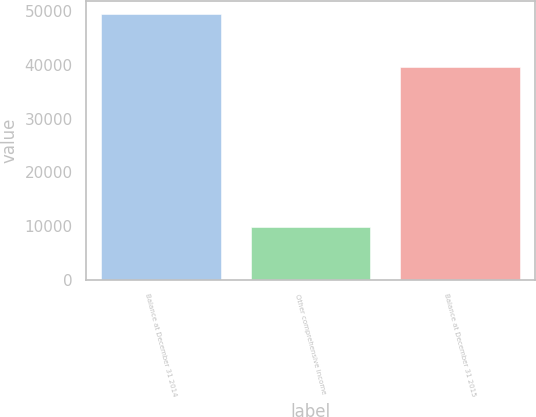<chart> <loc_0><loc_0><loc_500><loc_500><bar_chart><fcel>Balance at December 31 2014<fcel>Other comprehensive income<fcel>Balance at December 31 2015<nl><fcel>49356<fcel>9758<fcel>39598<nl></chart> 